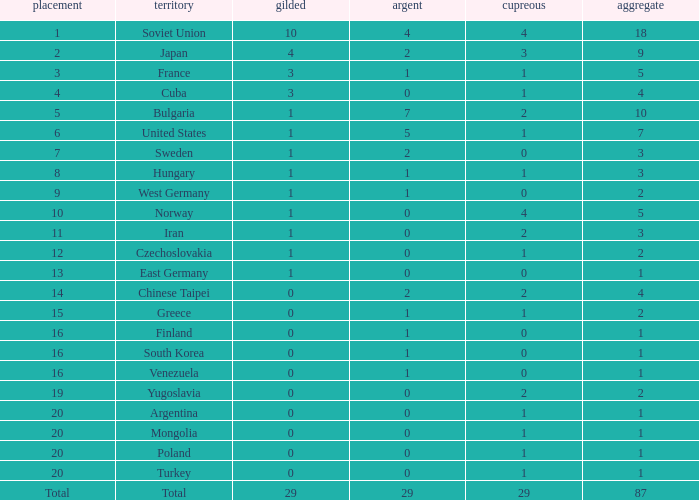Which rank has 1 silver medal and more than 1 gold medal? 3.0. 